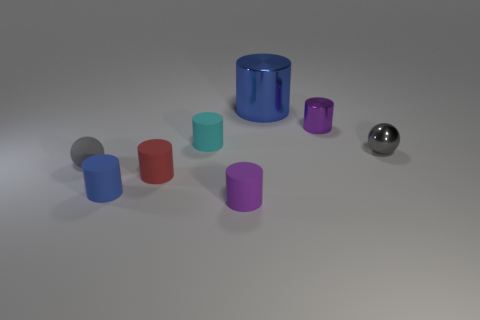What number of objects are yellow cylinders or matte objects that are behind the blue matte thing?
Your answer should be very brief. 3. The other matte cylinder that is the same color as the large cylinder is what size?
Give a very brief answer. Small. The blue thing that is in front of the large blue object has what shape?
Offer a very short reply. Cylinder. There is a metal cylinder that is in front of the blue metallic cylinder; is its color the same as the matte ball?
Offer a very short reply. No. What is the material of the other cylinder that is the same color as the big cylinder?
Provide a short and direct response. Rubber. There is a blue thing that is to the right of the cyan matte thing; does it have the same size as the blue rubber thing?
Ensure brevity in your answer.  No. Are there any big metal objects that have the same color as the big metallic cylinder?
Offer a terse response. No. Are there any rubber spheres that are to the right of the blue thing in front of the cyan thing?
Provide a succinct answer. No. Are there any tiny gray spheres that have the same material as the tiny red cylinder?
Keep it short and to the point. Yes. What material is the purple object that is to the right of the small purple cylinder that is to the left of the small metallic cylinder?
Give a very brief answer. Metal. 